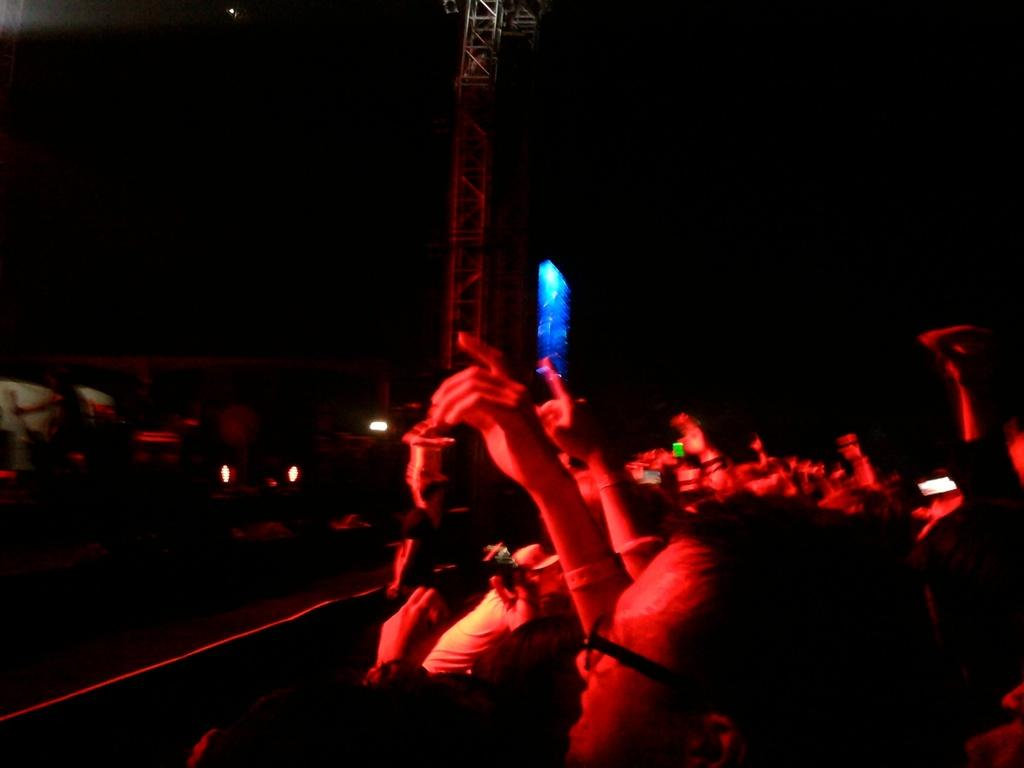How many people are in the image? There is a group of people in the image. Can you describe any specific features of one of the individuals in the group? A man in the group is wearing spectacles. What can be seen in the image besides the people? There are lights visible in the image. What is the condition of the background in the image? The background of the image is dark. What type of engine can be seen in the image? There is no engine present in the image. Can you tell me the name of the girl in the image? There is no girl mentioned in the provided facts, so we cannot determine her name. 